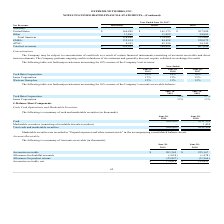According to Extreme Networks's financial document, Why does the company not require collateral in exchange for credit generally? The Company performs ongoing credit evaluations of its customers. The document states: "term investments. The Company performs ongoing credit evaluations of its customers and generally does not require collateral in exchange for credit...." Also, What was the percentage of net revenue occupied by Tech Data Corporation in 2017? According to the financial document, 16 (percentage). The relevant text states: "Tech Data Corporation 18% 14% 16%..." Also, Which years does the table provide information for major customers accounting for 10% or more of the Company’s net revenue? The document contains multiple relevant values: 2019, 2018, 2017. From the document: "Year Ended June 30, 2017 2019 2018..." Also, How many companies accounted for more than 15% of the company's net revenue in 2019? Counting the relevant items in the document: Tech Data Corporation, Jenne Corporation, I find 2 instances. The key data points involved are: Jenne Corporation, Tech Data Corporation. Also, can you calculate: What was the change in the percentage that Tech Data Corporation accounted for between 2018 and 2019? Based on the calculation: 18-14, the result is 4 (percentage). This is based on the information: "Tech Data Corporation 18% 14% 16% Tech Data Corporation 18% 14% 16%..." The key data points involved are: 14, 18. Also, can you calculate: How much did all three companies account for in the company's net revenue in 2017? Based on the calculation: 16+15+12, the result is 43 (percentage). This is based on the information: "Tech Data Corporation 18% 14% 16% Westcon Group Inc. 12% 13% 12% Jenne Corporation 17% 13% 15%..." The key data points involved are: 12, 15, 16. 